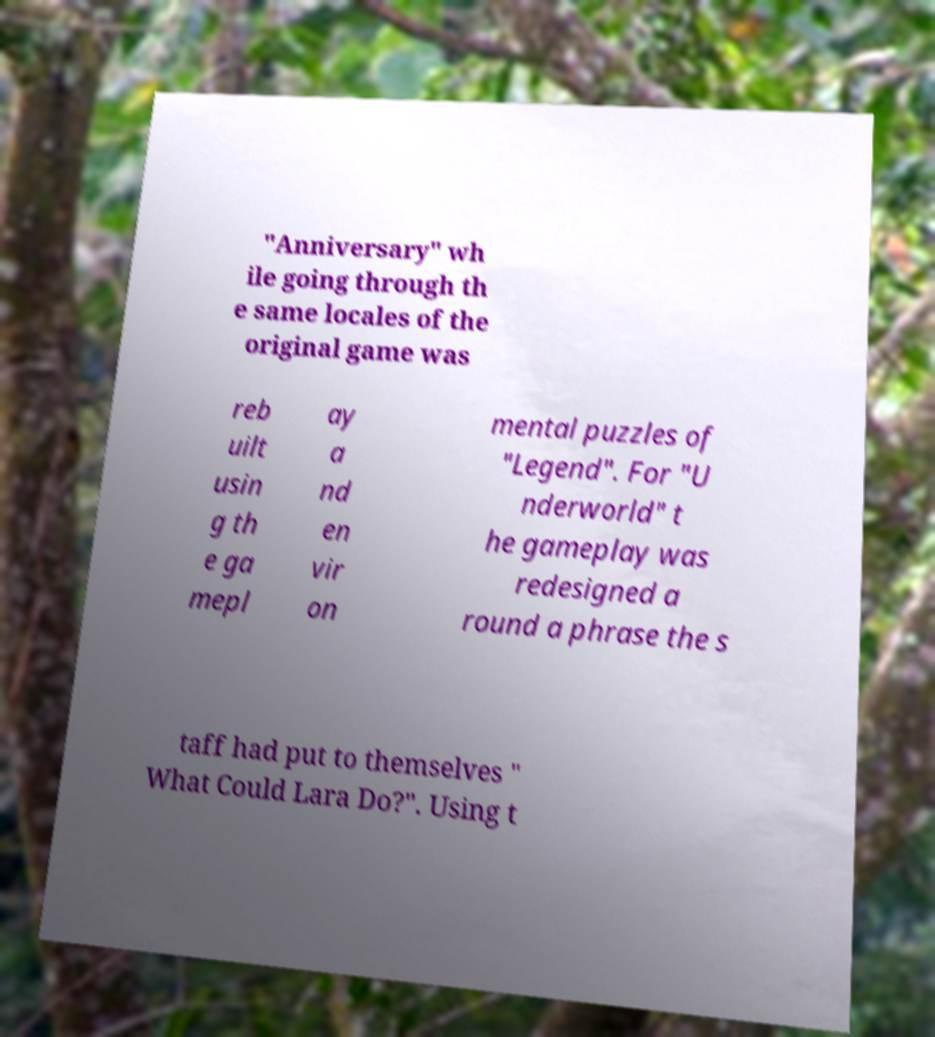I need the written content from this picture converted into text. Can you do that? "Anniversary" wh ile going through th e same locales of the original game was reb uilt usin g th e ga mepl ay a nd en vir on mental puzzles of "Legend". For "U nderworld" t he gameplay was redesigned a round a phrase the s taff had put to themselves " What Could Lara Do?". Using t 